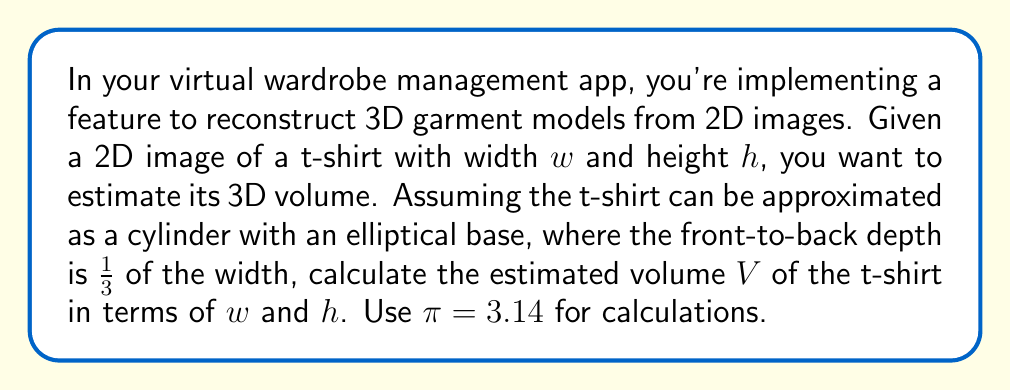Could you help me with this problem? To solve this problem, we'll follow these steps:

1) First, we need to identify the dimensions of our cylindrical approximation:
   - The height of the cylinder is $h$
   - The width of the elliptical base is $w$
   - The depth of the elliptical base is $\frac{1}{3}w$

2) The volume of a cylinder is given by the formula:
   $$V = \text{Area of base} \times \text{Height}$$

3) For an elliptical base, the area is calculated as:
   $$A = \pi \times a \times b$$
   where $a$ and $b$ are the semi-major and semi-minor axes of the ellipse.

4) In our case:
   $a = \frac{w}{2}$ (half the width)
   $b = \frac{1}{6}w$ (half the depth, which is $\frac{1}{3}$ of the width)

5) Substituting these into the area formula:
   $$A = \pi \times \frac{w}{2} \times \frac{w}{6} = \frac{\pi w^2}{12}$$

6) Now we can calculate the volume:
   $$V = A \times h = \frac{\pi w^2}{12} \times h = \frac{\pi w^2 h}{12}$$

7) Using $\pi = 3.14$, we get:
   $$V = \frac{3.14 w^2 h}{12} = 0.2617w^2h$$

Therefore, the estimated volume of the t-shirt is $0.2617w^2h$ cubic units.
Answer: $0.2617w^2h$ cubic units 